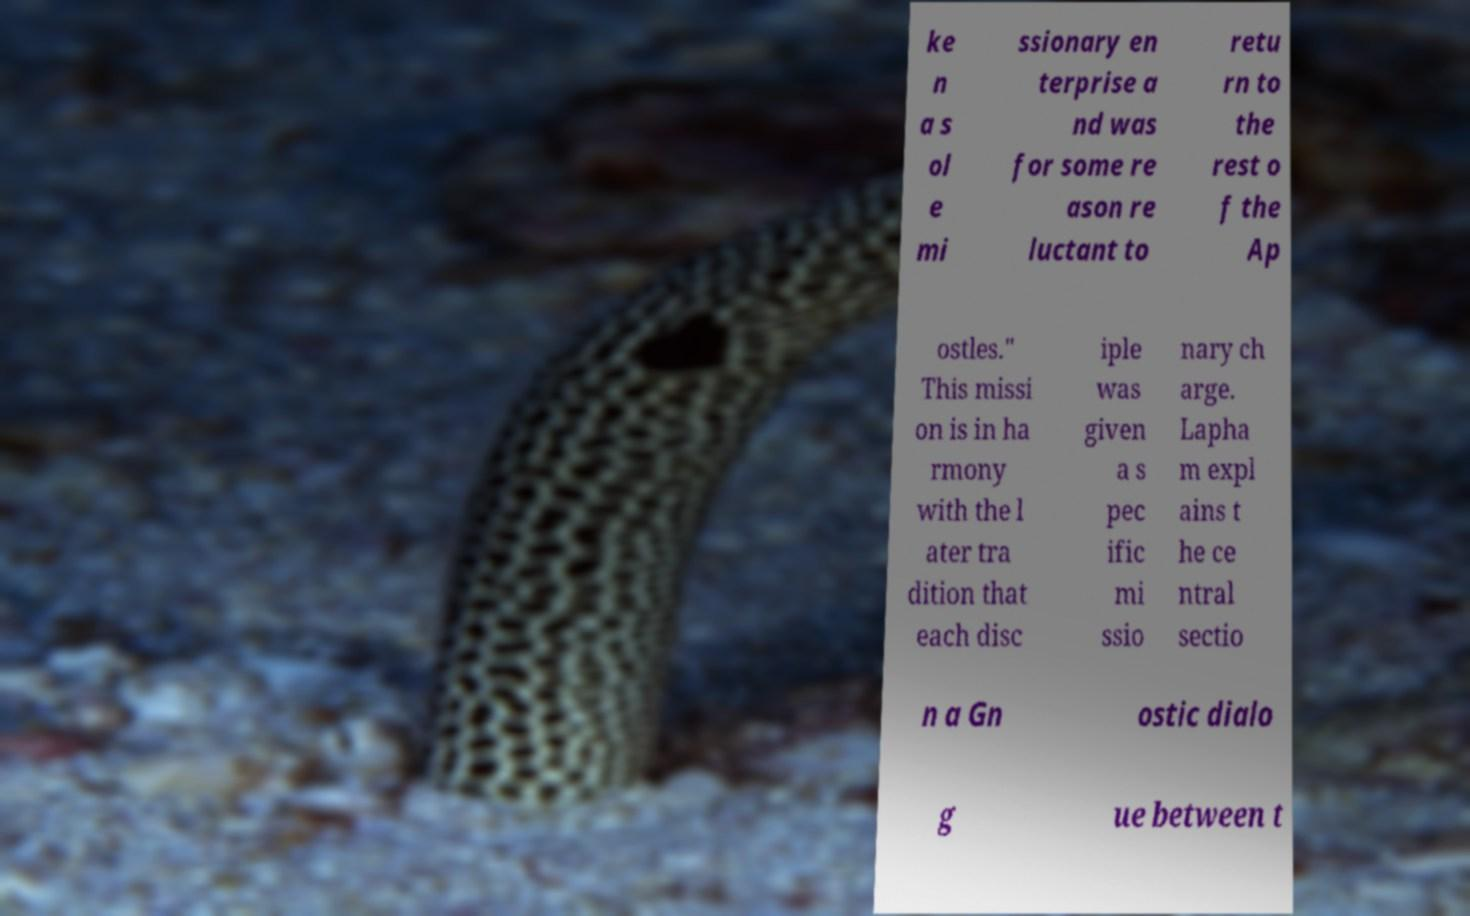There's text embedded in this image that I need extracted. Can you transcribe it verbatim? ke n a s ol e mi ssionary en terprise a nd was for some re ason re luctant to retu rn to the rest o f the Ap ostles." This missi on is in ha rmony with the l ater tra dition that each disc iple was given a s pec ific mi ssio nary ch arge. Lapha m expl ains t he ce ntral sectio n a Gn ostic dialo g ue between t 